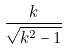Convert formula to latex. <formula><loc_0><loc_0><loc_500><loc_500>\frac { k } { \sqrt { k ^ { 2 } - 1 } }</formula> 